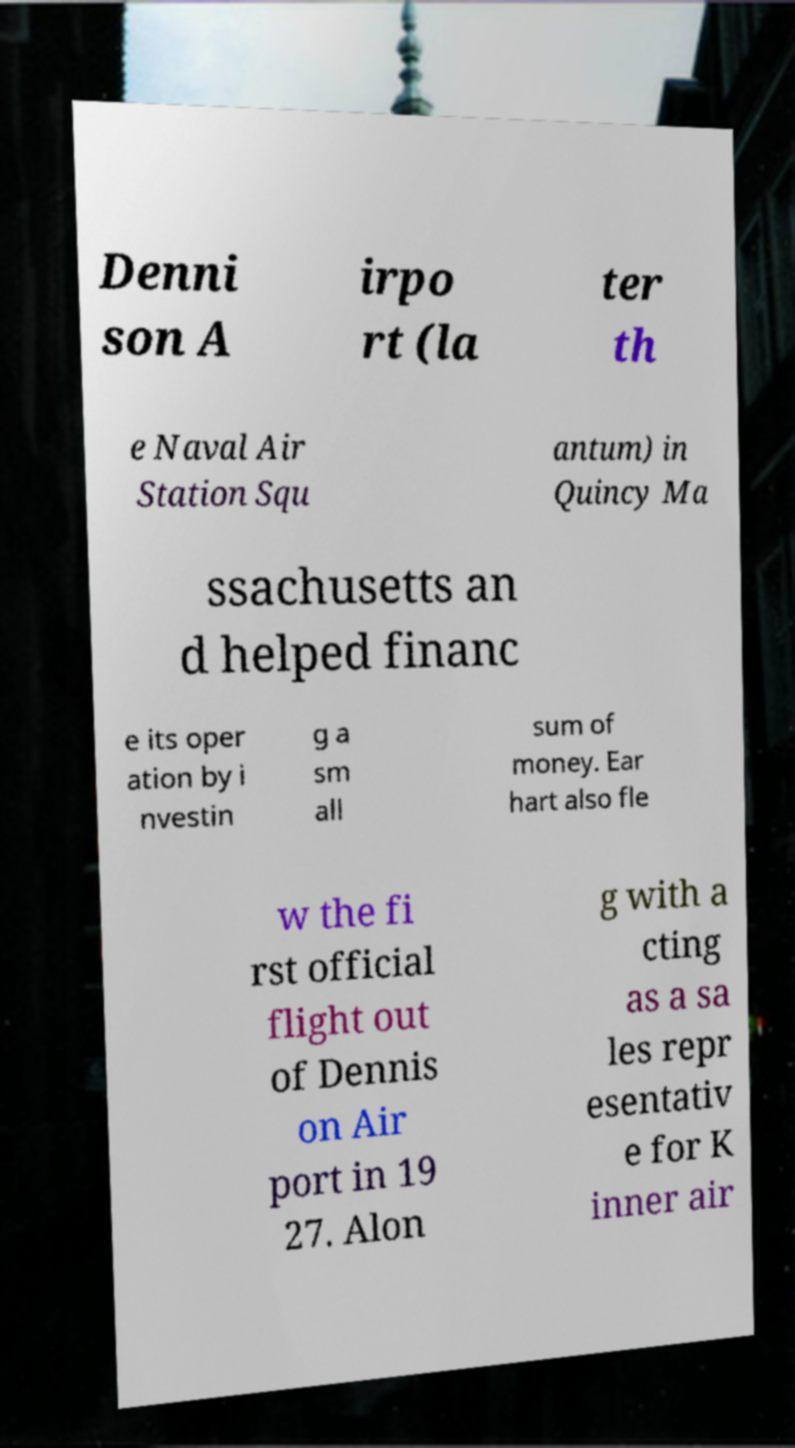I need the written content from this picture converted into text. Can you do that? Denni son A irpo rt (la ter th e Naval Air Station Squ antum) in Quincy Ma ssachusetts an d helped financ e its oper ation by i nvestin g a sm all sum of money. Ear hart also fle w the fi rst official flight out of Dennis on Air port in 19 27. Alon g with a cting as a sa les repr esentativ e for K inner air 